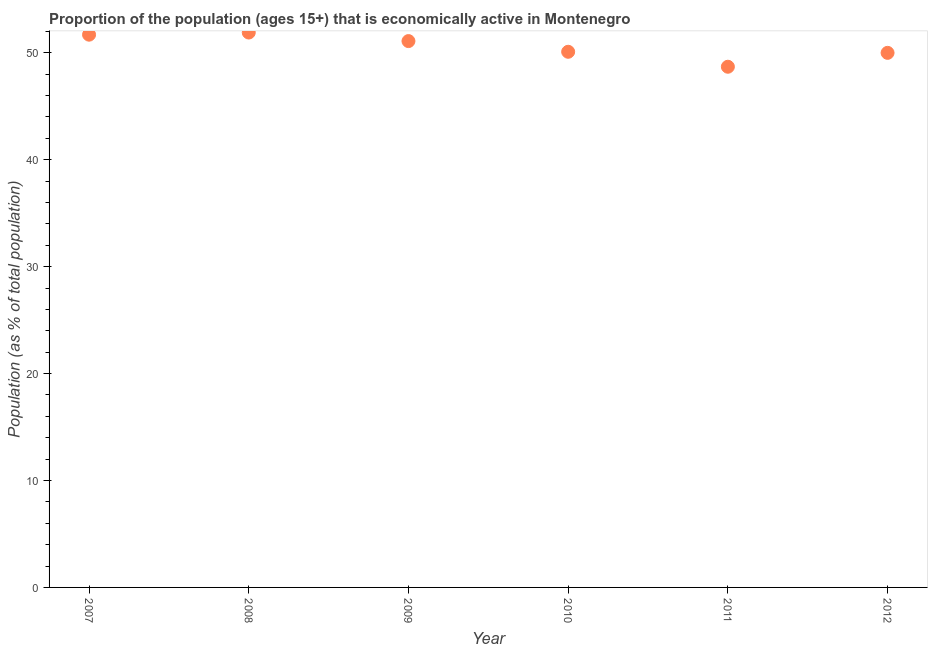What is the percentage of economically active population in 2011?
Your answer should be compact. 48.7. Across all years, what is the maximum percentage of economically active population?
Ensure brevity in your answer.  51.9. Across all years, what is the minimum percentage of economically active population?
Offer a very short reply. 48.7. What is the sum of the percentage of economically active population?
Offer a terse response. 303.5. What is the difference between the percentage of economically active population in 2008 and 2011?
Ensure brevity in your answer.  3.2. What is the average percentage of economically active population per year?
Your response must be concise. 50.58. What is the median percentage of economically active population?
Offer a very short reply. 50.6. What is the ratio of the percentage of economically active population in 2009 to that in 2012?
Keep it short and to the point. 1.02. Is the percentage of economically active population in 2009 less than that in 2012?
Offer a very short reply. No. Is the difference between the percentage of economically active population in 2009 and 2011 greater than the difference between any two years?
Provide a succinct answer. No. What is the difference between the highest and the second highest percentage of economically active population?
Offer a very short reply. 0.2. What is the difference between the highest and the lowest percentage of economically active population?
Your answer should be compact. 3.2. Are the values on the major ticks of Y-axis written in scientific E-notation?
Keep it short and to the point. No. What is the title of the graph?
Offer a terse response. Proportion of the population (ages 15+) that is economically active in Montenegro. What is the label or title of the X-axis?
Your answer should be compact. Year. What is the label or title of the Y-axis?
Make the answer very short. Population (as % of total population). What is the Population (as % of total population) in 2007?
Offer a terse response. 51.7. What is the Population (as % of total population) in 2008?
Give a very brief answer. 51.9. What is the Population (as % of total population) in 2009?
Make the answer very short. 51.1. What is the Population (as % of total population) in 2010?
Provide a succinct answer. 50.1. What is the Population (as % of total population) in 2011?
Provide a short and direct response. 48.7. What is the difference between the Population (as % of total population) in 2007 and 2012?
Ensure brevity in your answer.  1.7. What is the difference between the Population (as % of total population) in 2008 and 2009?
Provide a succinct answer. 0.8. What is the difference between the Population (as % of total population) in 2008 and 2010?
Provide a short and direct response. 1.8. What is the difference between the Population (as % of total population) in 2008 and 2012?
Offer a terse response. 1.9. What is the difference between the Population (as % of total population) in 2009 and 2010?
Your response must be concise. 1. What is the difference between the Population (as % of total population) in 2009 and 2011?
Give a very brief answer. 2.4. What is the difference between the Population (as % of total population) in 2009 and 2012?
Ensure brevity in your answer.  1.1. What is the difference between the Population (as % of total population) in 2010 and 2011?
Provide a succinct answer. 1.4. What is the difference between the Population (as % of total population) in 2010 and 2012?
Your response must be concise. 0.1. What is the ratio of the Population (as % of total population) in 2007 to that in 2008?
Your answer should be compact. 1. What is the ratio of the Population (as % of total population) in 2007 to that in 2009?
Give a very brief answer. 1.01. What is the ratio of the Population (as % of total population) in 2007 to that in 2010?
Provide a succinct answer. 1.03. What is the ratio of the Population (as % of total population) in 2007 to that in 2011?
Your response must be concise. 1.06. What is the ratio of the Population (as % of total population) in 2007 to that in 2012?
Your answer should be very brief. 1.03. What is the ratio of the Population (as % of total population) in 2008 to that in 2010?
Your answer should be compact. 1.04. What is the ratio of the Population (as % of total population) in 2008 to that in 2011?
Make the answer very short. 1.07. What is the ratio of the Population (as % of total population) in 2008 to that in 2012?
Provide a short and direct response. 1.04. What is the ratio of the Population (as % of total population) in 2009 to that in 2010?
Your answer should be very brief. 1.02. What is the ratio of the Population (as % of total population) in 2009 to that in 2011?
Your answer should be compact. 1.05. What is the ratio of the Population (as % of total population) in 2011 to that in 2012?
Give a very brief answer. 0.97. 